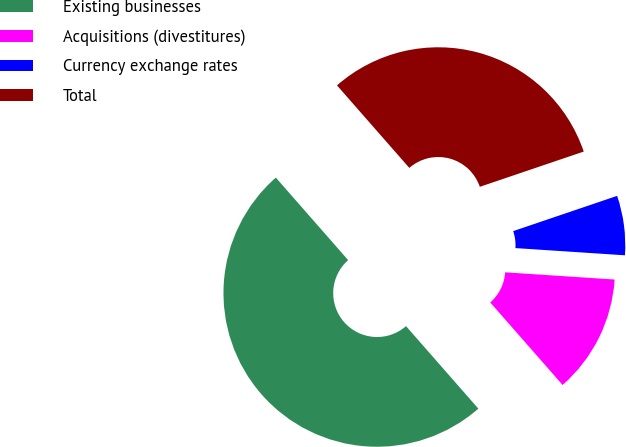Convert chart to OTSL. <chart><loc_0><loc_0><loc_500><loc_500><pie_chart><fcel>Existing businesses<fcel>Acquisitions (divestitures)<fcel>Currency exchange rates<fcel>Total<nl><fcel>50.0%<fcel>12.5%<fcel>6.25%<fcel>31.25%<nl></chart> 